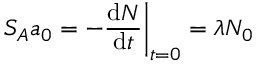<formula> <loc_0><loc_0><loc_500><loc_500>S _ { A } a _ { 0 } = - { \frac { d N } { d t } } { \Big | } _ { t = 0 } = \lambda N _ { 0 }</formula> 